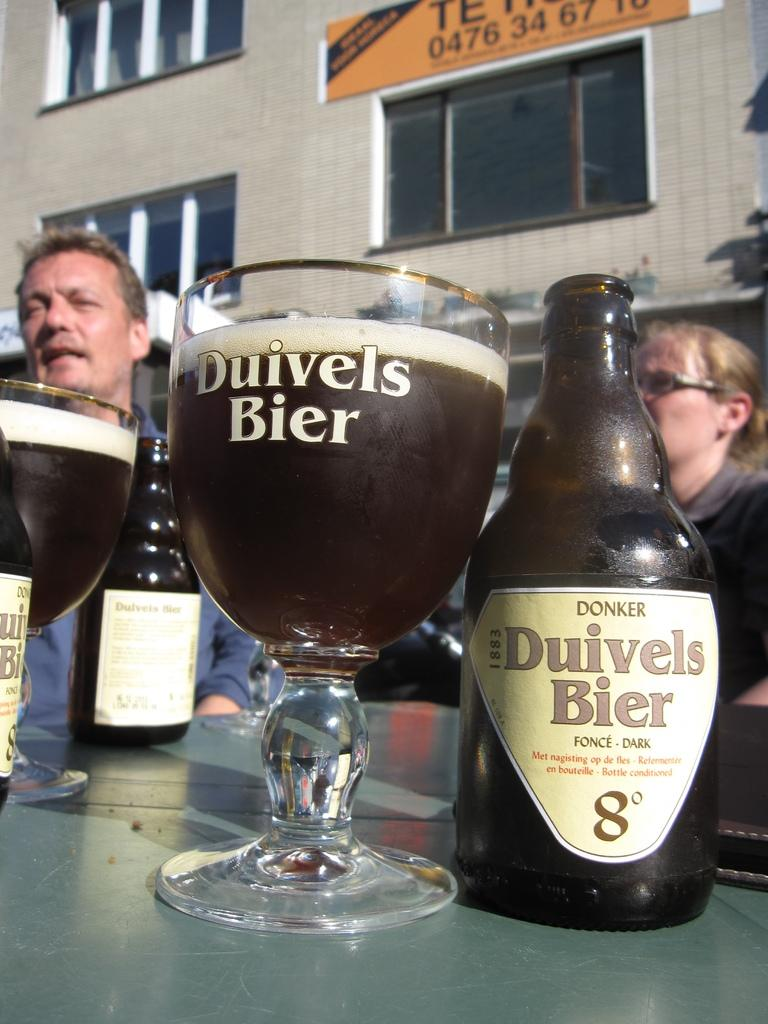<image>
Create a compact narrative representing the image presented. Two people sitting behind a glass of Duivels Bier. 